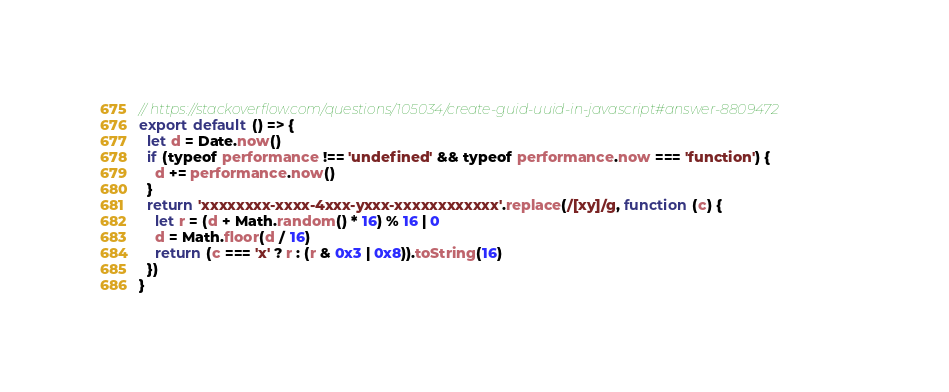Convert code to text. <code><loc_0><loc_0><loc_500><loc_500><_JavaScript_>// https://stackoverflow.com/questions/105034/create-guid-uuid-in-javascript#answer-8809472
export default () => {
  let d = Date.now()
  if (typeof performance !== 'undefined' && typeof performance.now === 'function') {
    d += performance.now()
  }
  return 'xxxxxxxx-xxxx-4xxx-yxxx-xxxxxxxxxxxx'.replace(/[xy]/g, function (c) {
    let r = (d + Math.random() * 16) % 16 | 0
    d = Math.floor(d / 16)
    return (c === 'x' ? r : (r & 0x3 | 0x8)).toString(16)
  })
}
</code> 